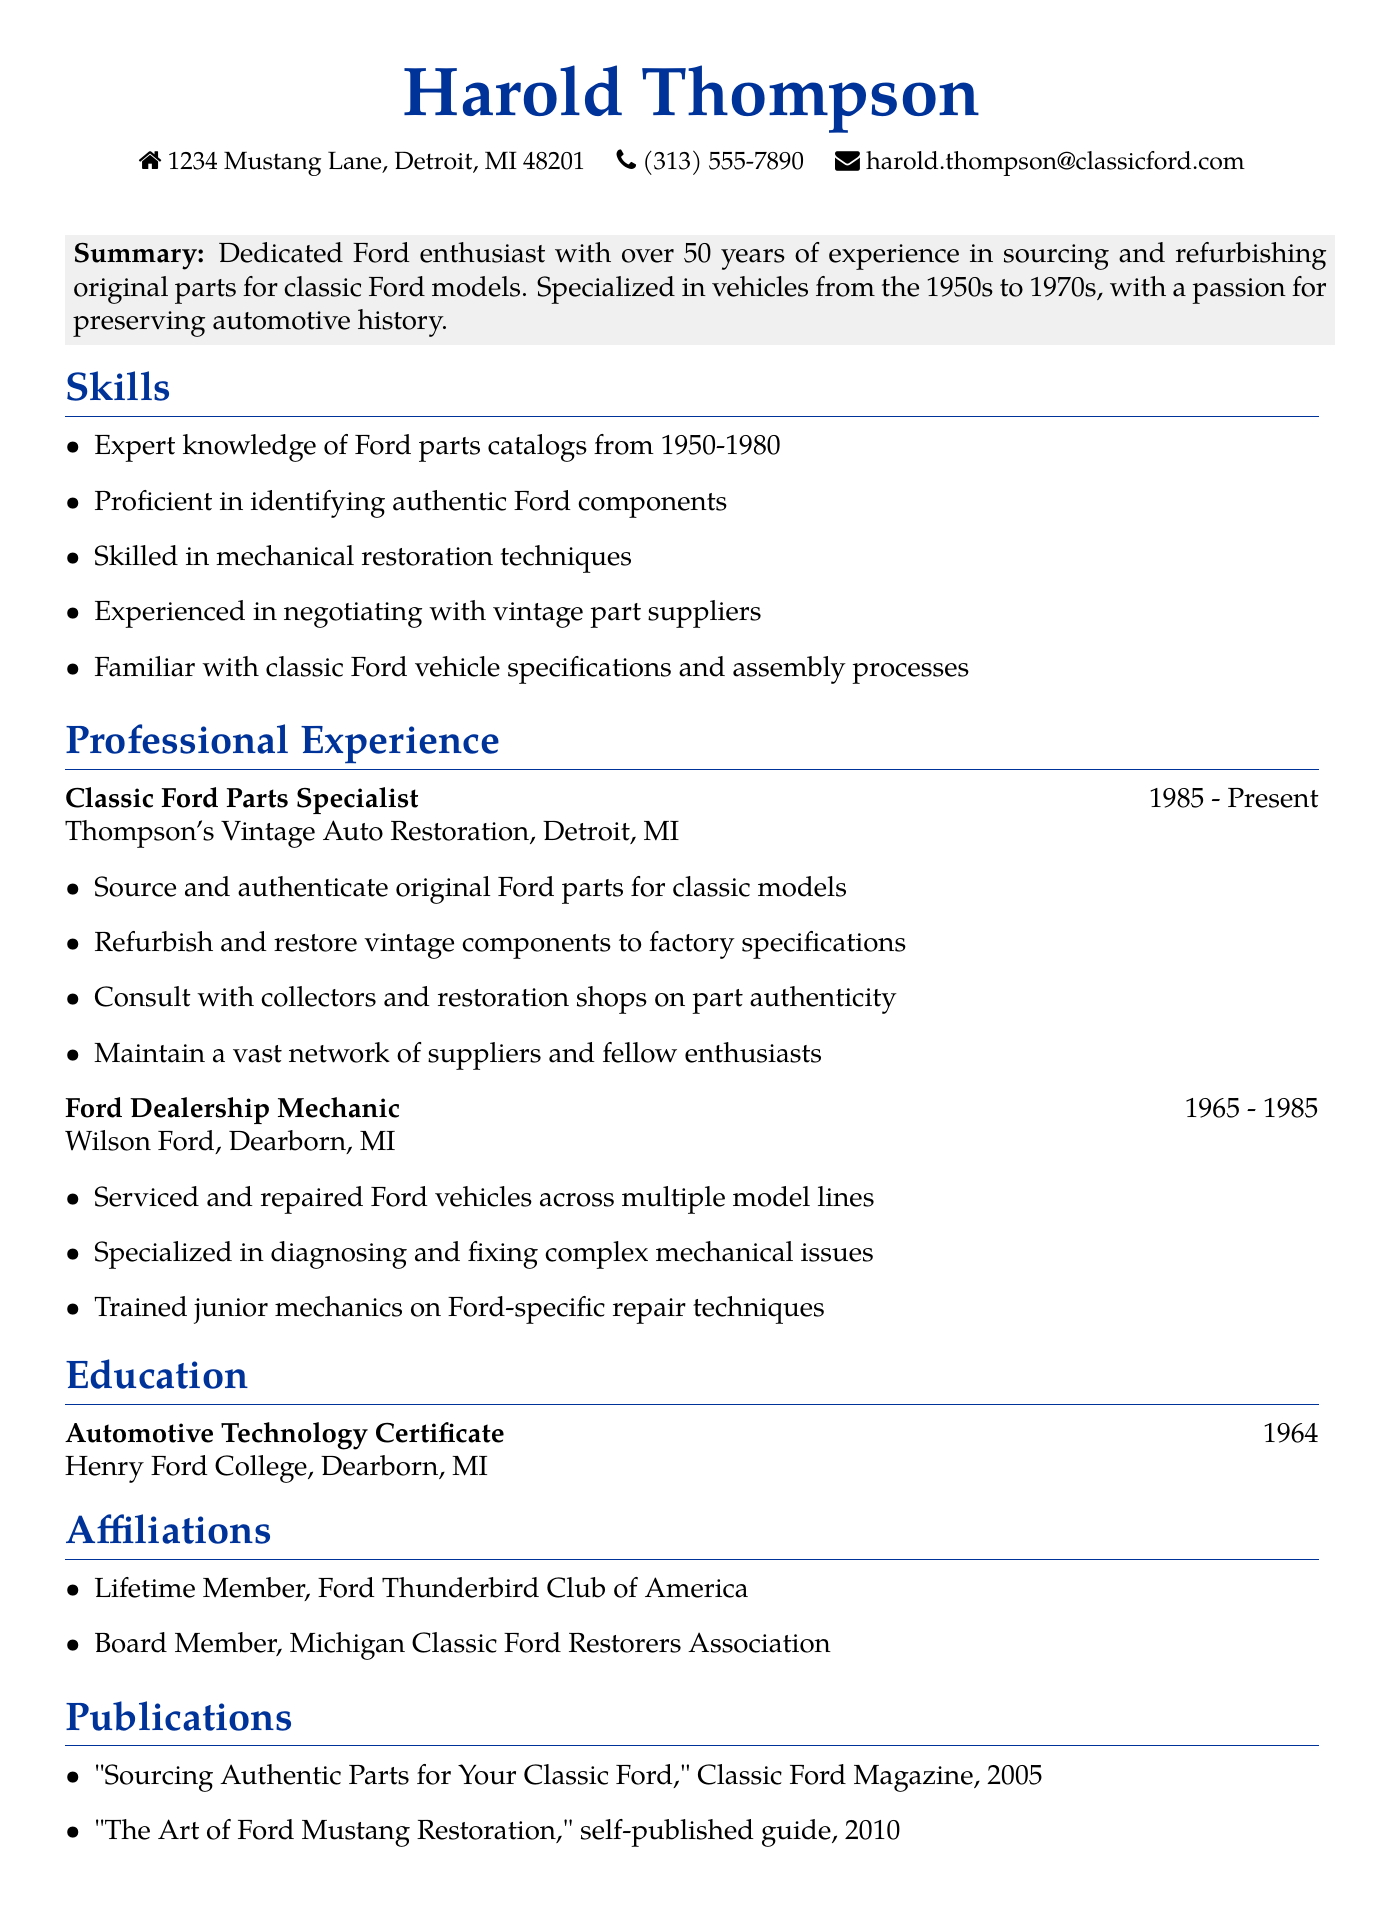What is the name of the individual? The name of the individual is stated at the beginning of the document.
Answer: Harold Thompson What is the location of the individual's current job? The location of Thompson's Vintage Auto Restoration is mentioned in the experience section.
Answer: Detroit, MI How many years of experience does Harold Thompson have? The summary section indicates "over 50 years of experience."
Answer: 50 years What is the degree obtained by Harold Thompson? The education section specifies the degree he obtained.
Answer: Automotive Technology Certificate Which club is Harold a lifetime member of? The affiliations section lists the clubs he is part of.
Answer: Ford Thunderbird Club of America What is one skill related to Ford parts catalogs? The skills section includes specific knowledge related to Ford parts.
Answer: Expert knowledge of Ford parts catalogs from 1950-1980 In which year was the publication "The Art of Ford Mustang Restoration" released? The publications section provides the year for the self-published guide.
Answer: 2010 What was Harold's job title at Wilson Ford? The experience section specifies his job title during his time at Wilson Ford.
Answer: Ford Dealership Mechanic What is one of the responsibilities of a Classic Ford Parts Specialist? The experience section outlines specific duties associated with the role.
Answer: Source and authenticate original Ford parts for classic models 